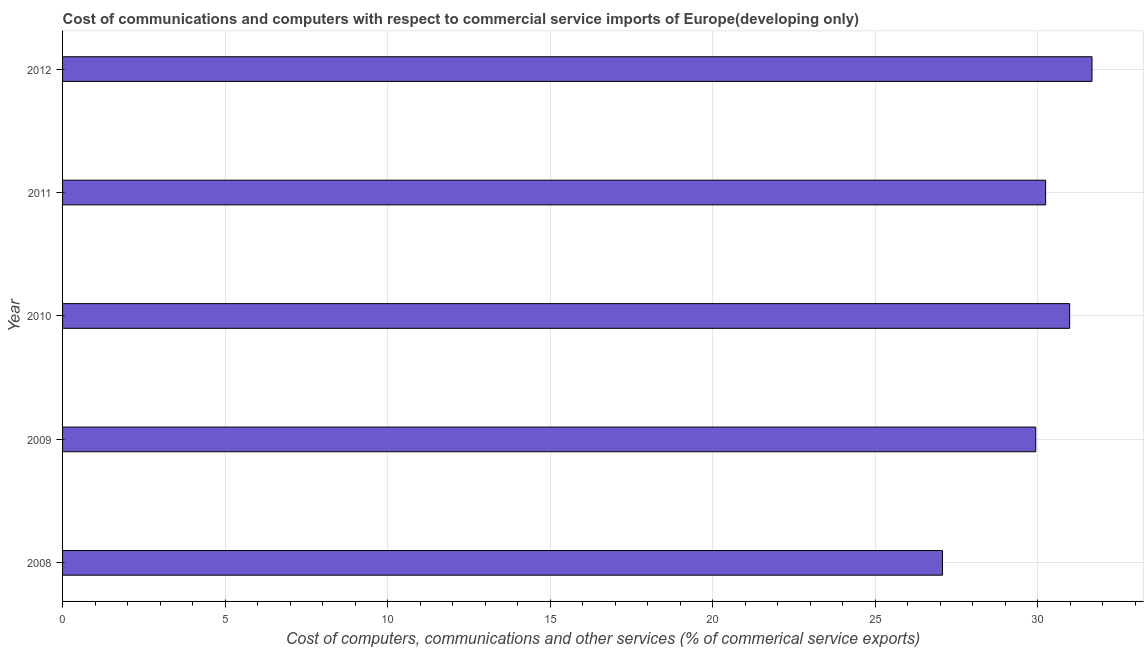Does the graph contain grids?
Offer a terse response. Yes. What is the title of the graph?
Make the answer very short. Cost of communications and computers with respect to commercial service imports of Europe(developing only). What is the label or title of the X-axis?
Your answer should be compact. Cost of computers, communications and other services (% of commerical service exports). What is the label or title of the Y-axis?
Provide a succinct answer. Year. What is the cost of communications in 2010?
Your response must be concise. 30.98. Across all years, what is the maximum  computer and other services?
Keep it short and to the point. 31.66. Across all years, what is the minimum  computer and other services?
Keep it short and to the point. 27.07. In which year was the  computer and other services maximum?
Your answer should be compact. 2012. What is the sum of the cost of communications?
Your answer should be compact. 149.88. What is the difference between the  computer and other services in 2009 and 2010?
Your answer should be compact. -1.04. What is the average cost of communications per year?
Your answer should be compact. 29.98. What is the median cost of communications?
Make the answer very short. 30.24. In how many years, is the cost of communications greater than 1 %?
Provide a short and direct response. 5. Is the cost of communications in 2011 less than that in 2012?
Your response must be concise. Yes. Is the difference between the cost of communications in 2009 and 2011 greater than the difference between any two years?
Your response must be concise. No. What is the difference between the highest and the second highest  computer and other services?
Offer a terse response. 0.69. Is the sum of the cost of communications in 2008 and 2010 greater than the maximum cost of communications across all years?
Offer a very short reply. Yes. Are all the bars in the graph horizontal?
Ensure brevity in your answer.  Yes. What is the difference between two consecutive major ticks on the X-axis?
Offer a very short reply. 5. Are the values on the major ticks of X-axis written in scientific E-notation?
Your answer should be compact. No. What is the Cost of computers, communications and other services (% of commerical service exports) in 2008?
Offer a very short reply. 27.07. What is the Cost of computers, communications and other services (% of commerical service exports) of 2009?
Ensure brevity in your answer.  29.93. What is the Cost of computers, communications and other services (% of commerical service exports) of 2010?
Offer a very short reply. 30.98. What is the Cost of computers, communications and other services (% of commerical service exports) of 2011?
Your answer should be compact. 30.24. What is the Cost of computers, communications and other services (% of commerical service exports) in 2012?
Offer a very short reply. 31.66. What is the difference between the Cost of computers, communications and other services (% of commerical service exports) in 2008 and 2009?
Provide a succinct answer. -2.87. What is the difference between the Cost of computers, communications and other services (% of commerical service exports) in 2008 and 2010?
Make the answer very short. -3.91. What is the difference between the Cost of computers, communications and other services (% of commerical service exports) in 2008 and 2011?
Make the answer very short. -3.17. What is the difference between the Cost of computers, communications and other services (% of commerical service exports) in 2008 and 2012?
Your answer should be compact. -4.6. What is the difference between the Cost of computers, communications and other services (% of commerical service exports) in 2009 and 2010?
Provide a short and direct response. -1.04. What is the difference between the Cost of computers, communications and other services (% of commerical service exports) in 2009 and 2011?
Ensure brevity in your answer.  -0.3. What is the difference between the Cost of computers, communications and other services (% of commerical service exports) in 2009 and 2012?
Your response must be concise. -1.73. What is the difference between the Cost of computers, communications and other services (% of commerical service exports) in 2010 and 2011?
Provide a succinct answer. 0.74. What is the difference between the Cost of computers, communications and other services (% of commerical service exports) in 2010 and 2012?
Ensure brevity in your answer.  -0.69. What is the difference between the Cost of computers, communications and other services (% of commerical service exports) in 2011 and 2012?
Give a very brief answer. -1.43. What is the ratio of the Cost of computers, communications and other services (% of commerical service exports) in 2008 to that in 2009?
Provide a short and direct response. 0.9. What is the ratio of the Cost of computers, communications and other services (% of commerical service exports) in 2008 to that in 2010?
Make the answer very short. 0.87. What is the ratio of the Cost of computers, communications and other services (% of commerical service exports) in 2008 to that in 2011?
Provide a succinct answer. 0.9. What is the ratio of the Cost of computers, communications and other services (% of commerical service exports) in 2008 to that in 2012?
Your answer should be very brief. 0.85. What is the ratio of the Cost of computers, communications and other services (% of commerical service exports) in 2009 to that in 2010?
Provide a short and direct response. 0.97. What is the ratio of the Cost of computers, communications and other services (% of commerical service exports) in 2009 to that in 2011?
Your response must be concise. 0.99. What is the ratio of the Cost of computers, communications and other services (% of commerical service exports) in 2009 to that in 2012?
Give a very brief answer. 0.94. What is the ratio of the Cost of computers, communications and other services (% of commerical service exports) in 2010 to that in 2011?
Ensure brevity in your answer.  1.02. What is the ratio of the Cost of computers, communications and other services (% of commerical service exports) in 2011 to that in 2012?
Offer a very short reply. 0.95. 